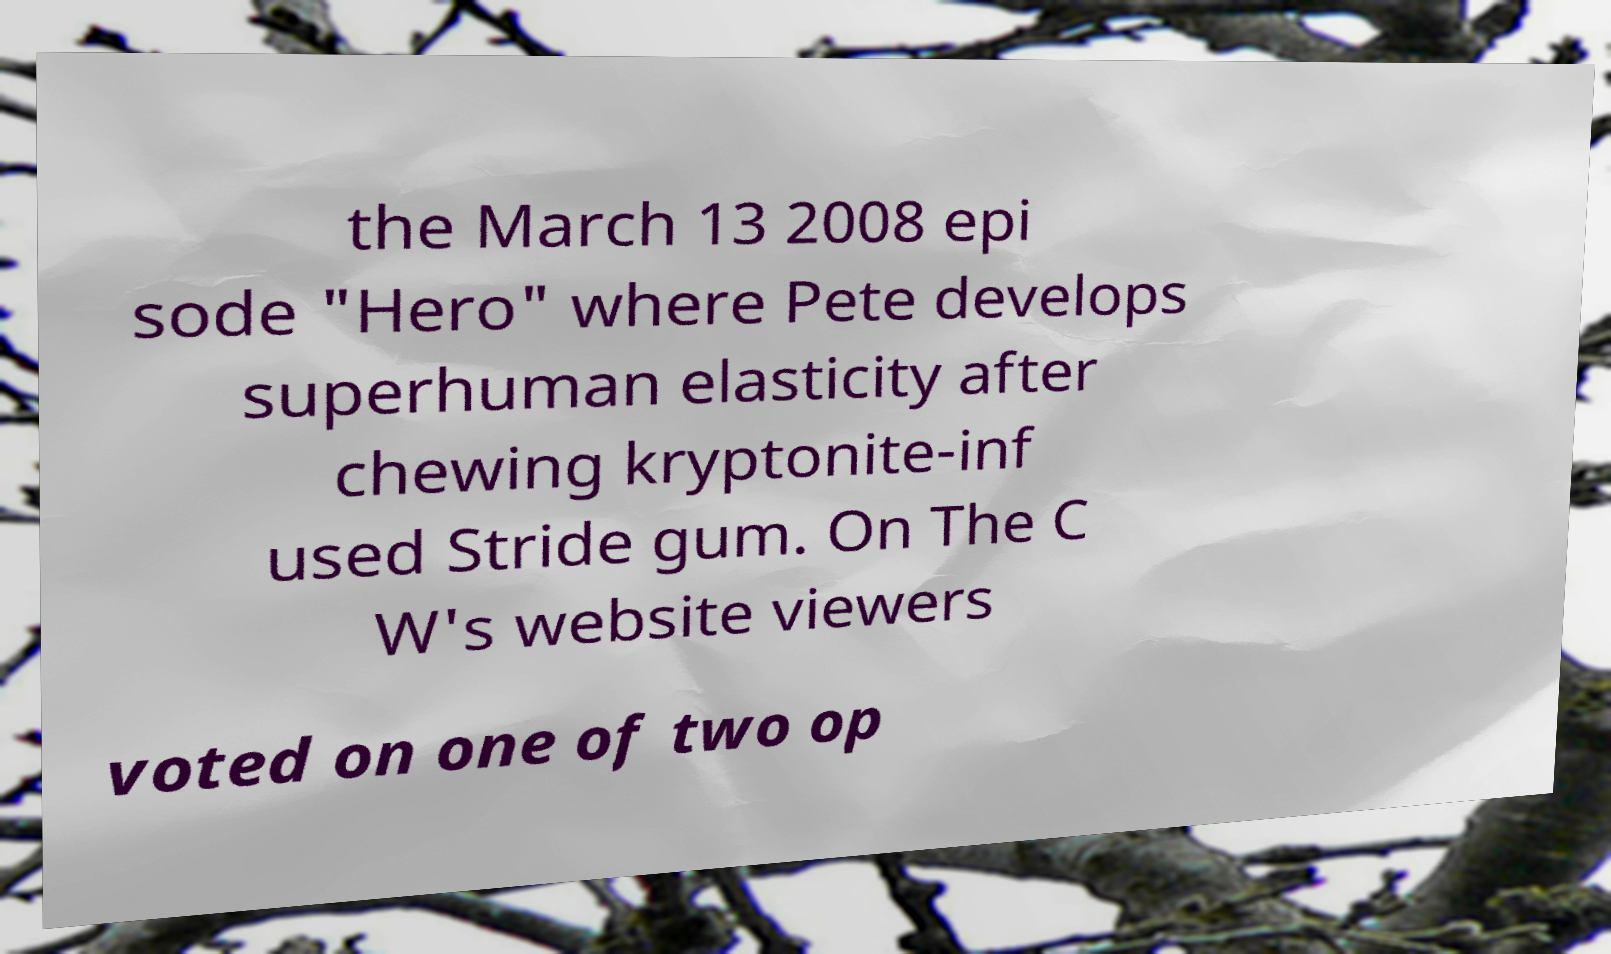Can you accurately transcribe the text from the provided image for me? the March 13 2008 epi sode "Hero" where Pete develops superhuman elasticity after chewing kryptonite-inf used Stride gum. On The C W's website viewers voted on one of two op 